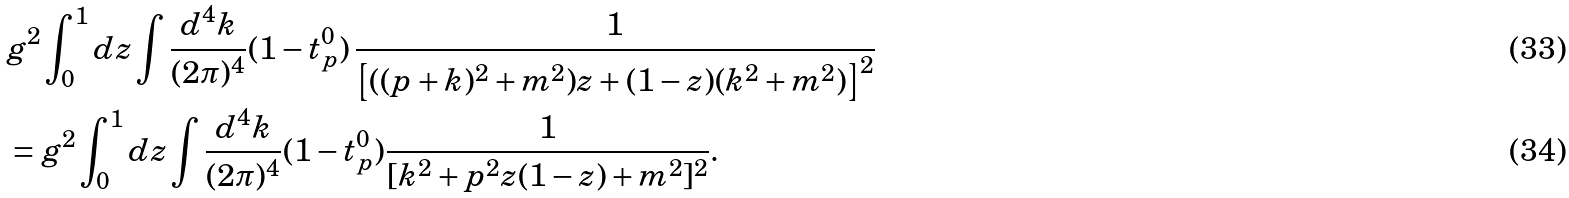<formula> <loc_0><loc_0><loc_500><loc_500>& g ^ { 2 } \int _ { 0 } ^ { 1 } d z \int \frac { d ^ { 4 } k } { ( 2 \pi ) ^ { 4 } } ( 1 - t ^ { 0 } _ { p } ) \, \frac { 1 } { \left [ ( ( p + k ) ^ { 2 } + m ^ { 2 } ) z + ( 1 - z ) ( k ^ { 2 } + m ^ { 2 } ) \right ] ^ { 2 } } \\ & = g ^ { 2 } \int _ { 0 } ^ { 1 } d z \int \frac { d ^ { 4 } k } { ( 2 \pi ) ^ { 4 } } ( 1 - t ^ { 0 } _ { p } ) \frac { 1 } { [ k ^ { 2 } + p ^ { 2 } z ( 1 - z ) + m ^ { 2 } ] ^ { 2 } } .</formula> 